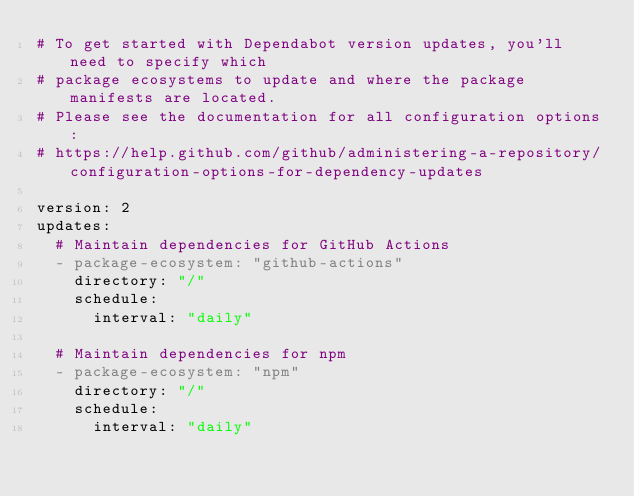<code> <loc_0><loc_0><loc_500><loc_500><_YAML_># To get started with Dependabot version updates, you'll need to specify which
# package ecosystems to update and where the package manifests are located.
# Please see the documentation for all configuration options:
# https://help.github.com/github/administering-a-repository/configuration-options-for-dependency-updates

version: 2
updates:
  # Maintain dependencies for GitHub Actions
  - package-ecosystem: "github-actions"
    directory: "/"
    schedule:
      interval: "daily"

  # Maintain dependencies for npm
  - package-ecosystem: "npm"
    directory: "/"
    schedule:
      interval: "daily"
</code> 